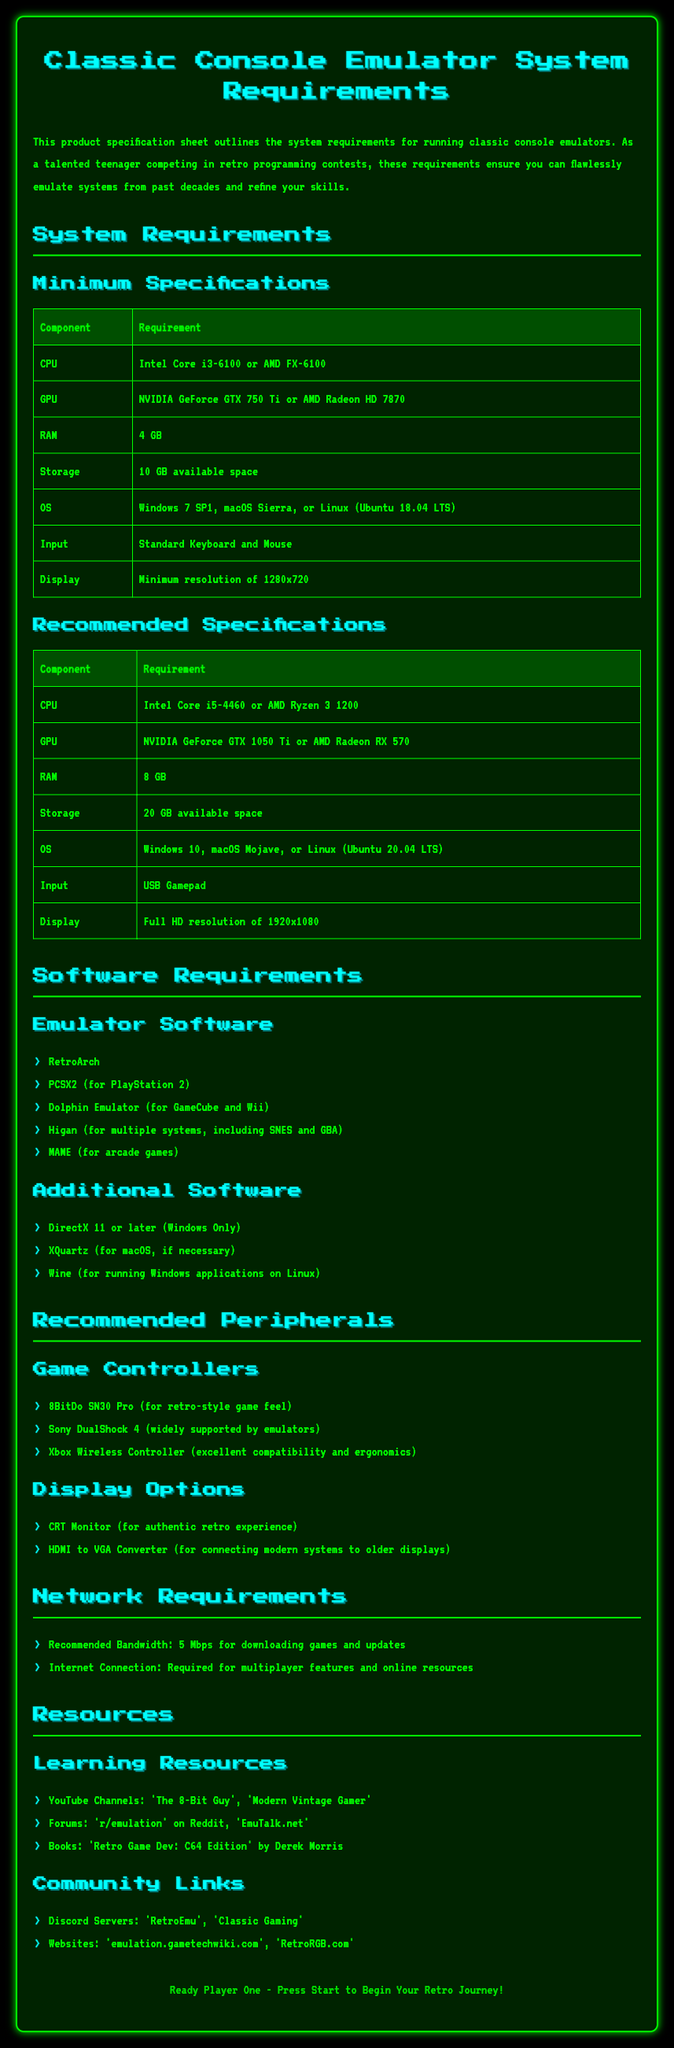What is the minimum RAM requirement? The minimum RAM requirement is specified under Minimum Specifications in the document.
Answer: 4 GB What is the recommended GPU? The recommended GPU can be found under Recommended Specifications in the document.
Answer: NVIDIA GeForce GTX 1050 Ti Which operating system is required for minimum specifications? The minimum operating system requirements are listed in the Minimum Specifications section.
Answer: Windows 7 SP1, macOS Sierra, or Linux (Ubuntu 18.04 LTS) How much storage is needed for recommended specifications? The storage requirement is detailed under Recommended Specifications.
Answer: 20 GB available space What is the recommended bandwidth for network requirements? The network requirements specify the recommended bandwidth in the document.
Answer: 5 Mbps What is the purpose of the CRT Monitor listed under Display Options? The CRT Monitor is mentioned in the Recommended Peripherals section for its specific benefit.
Answer: For authentic retro experience How many emulator software options are listed? The number of emulator software options can be counted from the Emulator Software section.
Answer: 5 What type of input is specified in the Minimum Specifications? The minimum input requirement is stated in the Minimum Specifications section of the document.
Answer: Standard Keyboard and Mouse What additional software is needed for macOS? The additional software requirement for macOS is specified in the Additional Software section.
Answer: XQuartz 